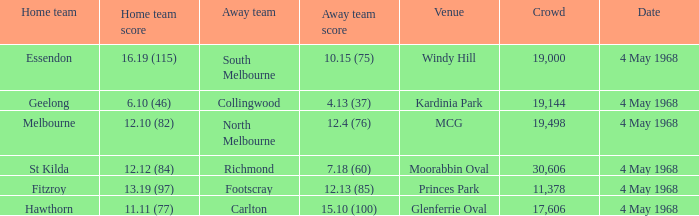What team played at Moorabbin Oval to a crowd of 19,144? St Kilda. 